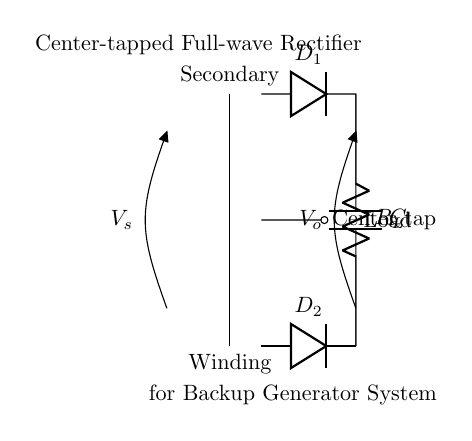What is the type of rectifier shown in the diagram? The diagram depicts a center-tapped full-wave rectifier, which is characterized by the use of a center-tapped transformer and two diodes.
Answer: center-tapped full-wave rectifier How many diodes are present in this circuit? The circuit has two diodes, labeled D1 and D2, which are used to rectify the AC voltage produced by the transformer.
Answer: 2 What is the function of the capacitor in this rectifier circuit? The capacitor's purpose is to smooth out the pulsating DC output voltage produced by the rectification process, helping to reduce ripple voltage.
Answer: smooth output What is the load resistance labeled in the circuit? The load resistor is indicated by R_L in the circuit, connecting the output of the rectification process to the load.
Answer: R_L How is the output voltage indicated in the diagram? The output voltage is represented by V_o, which is the voltage across the load resistance (R_L) and capacitor (C) in the circuit.
Answer: V_o What is connected at the center tap of the transformer? The center tap of the transformer connects to the ground or reference point for the rectifier, serving as a neutral point for the two diodes.
Answer: ground How does the current flow through the circuit during one half of the AC cycle? During one half of the AC cycle, one diode (D1 or D2) conducts while the other is reverse-biased, allowing current to flow through the load and charge the capacitor, providing a unidirectional current.
Answer: one diode conducts 